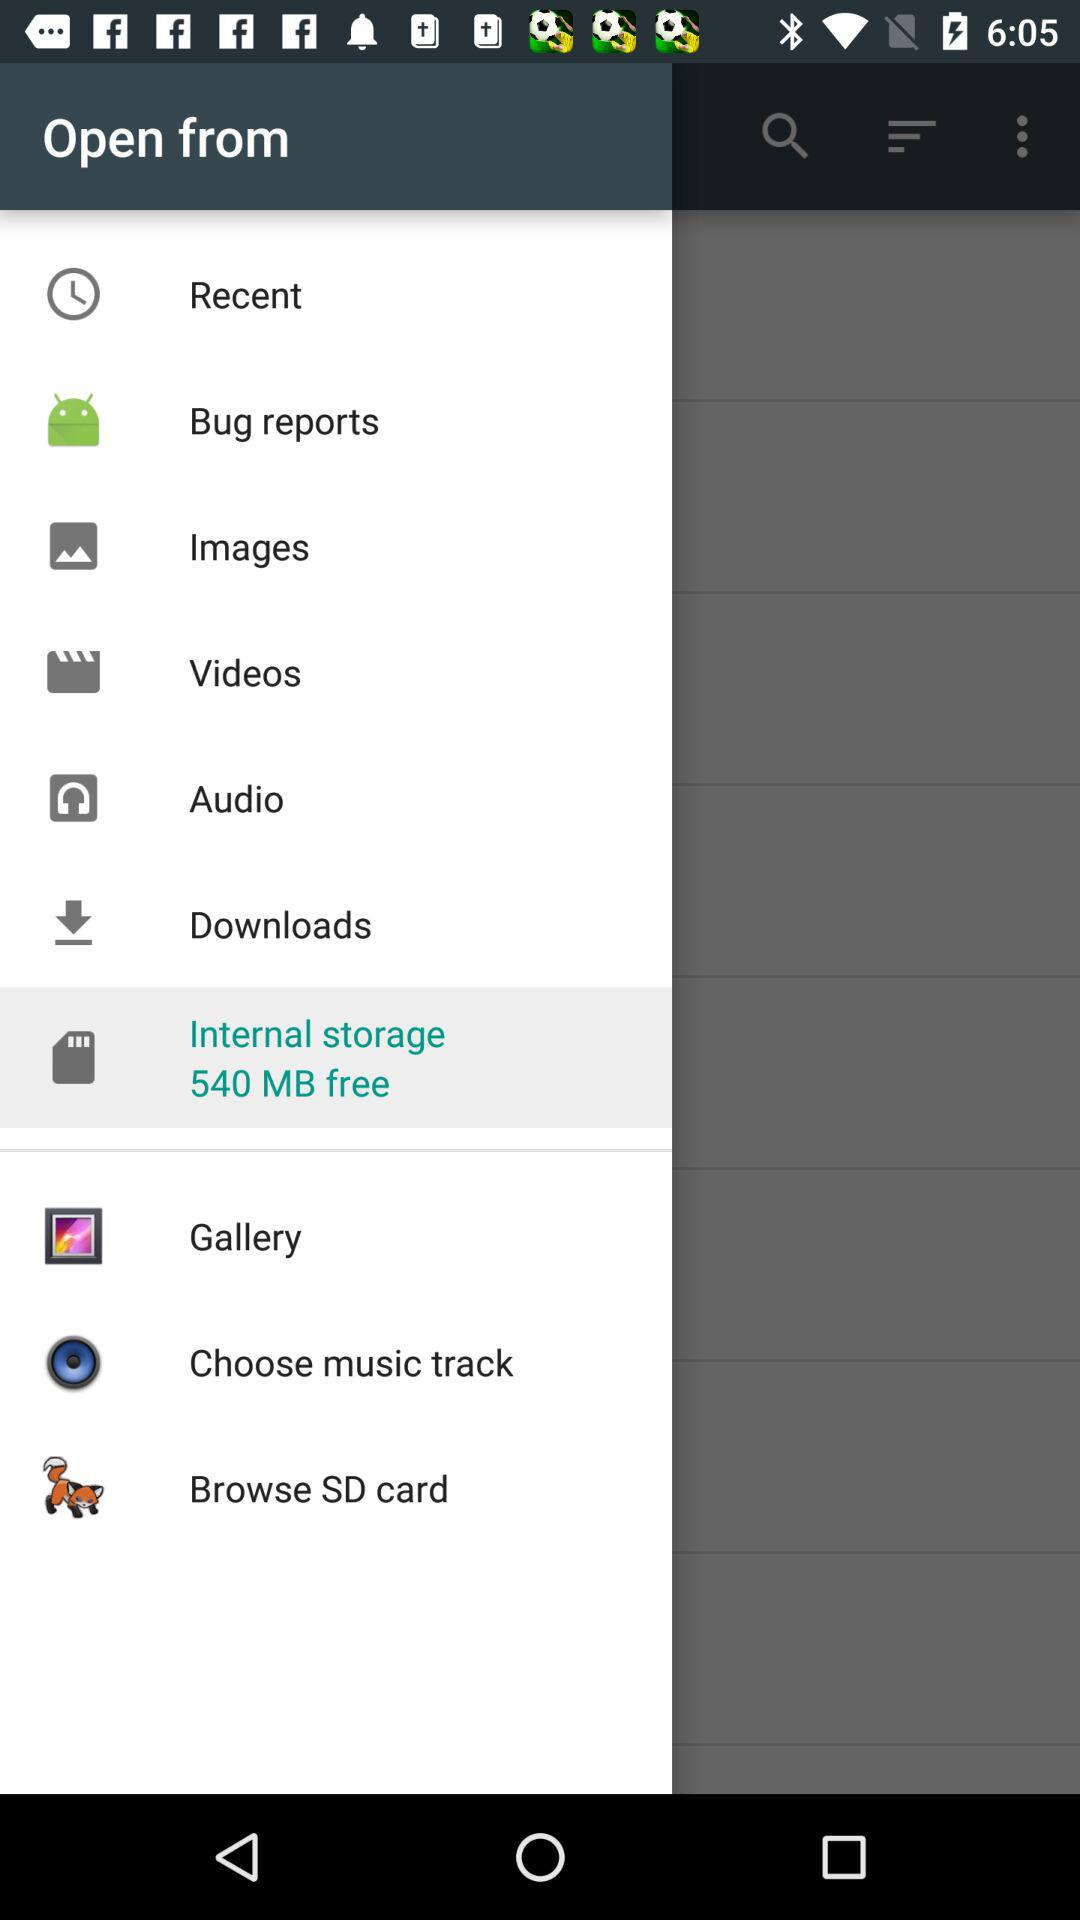How much free space is there in internal storage? There is 540 MB free space in internal storage. 